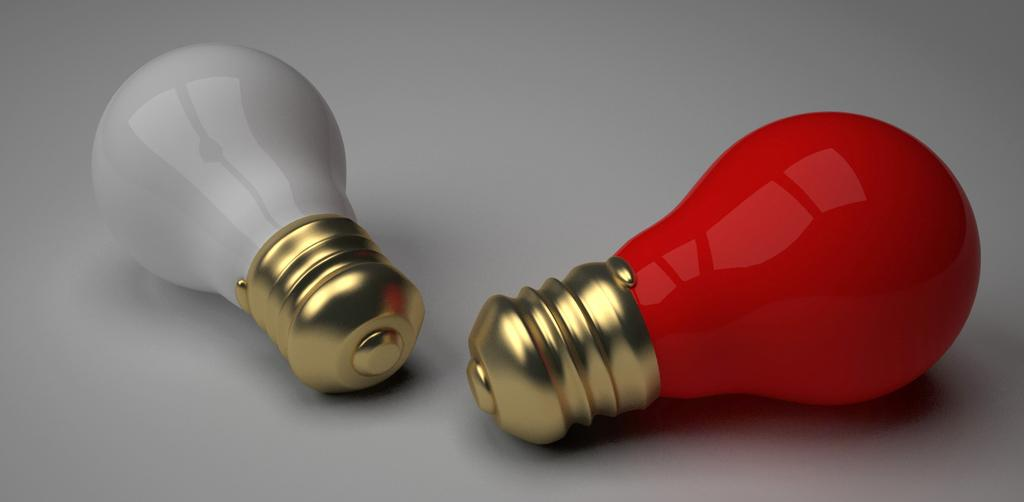What colors of bulbs are present in the image? There are white and red bulbs in the image. What is the color of the surface on which the bulbs are placed? The bulbs are on a white surface. What type of border is visible around the bulbs in the image? There is no border visible around the bulbs in the image. What kind of coach is present in the image? There is no coach present in the image. 